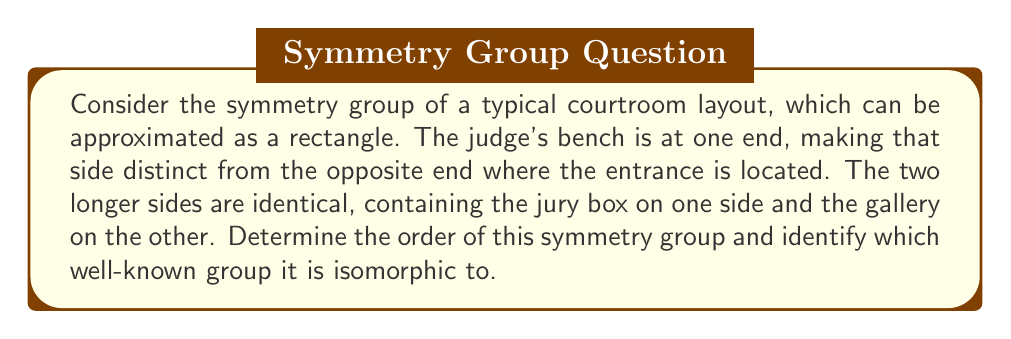Give your solution to this math problem. Let's approach this step-by-step:

1) First, we need to identify the symmetries of this courtroom layout:
   - The courtroom can be rotated 180° around its center (2-fold rotation).
   - The courtroom can be reflected across its central axis (line of symmetry running from the judge's bench to the entrance).

2) These symmetries form a group under composition. Let's call them:
   - e: identity transformation
   - r: 180° rotation
   - f: reflection

3) We can create a Cayley table for this group:

   $$\begin{array}{c|ccc}
   \circ & e & r & f \\
   \hline
   e & e & r & f \\
   r & r & e & f \\
   f & f & f & e
   \end{array}$$

4) From this table, we can observe:
   - The group has order 3
   - It is non-commutative (rf ≠ fr)
   - $r^2 = e$, $f^2 = e$, and $rf = fr = f$

5) These properties uniquely identify this group as isomorphic to the dihedral group $D_1$, also known as the symmetry group of a non-square rectangle.

6) In abstract algebra notation, this group can be presented as:
   $$\langle r, f \mid r^2 = f^2 = e, rf = fr \rangle$$

This group structure reflects the legal principle of equality before the law, as embodied in the symmetrical layout of the courtroom, while also acknowledging the distinct roles of different parts of the court (judge's bench vs. entrance).
Answer: The symmetry group of the courtroom layout has order 3 and is isomorphic to the dihedral group $D_1$. 